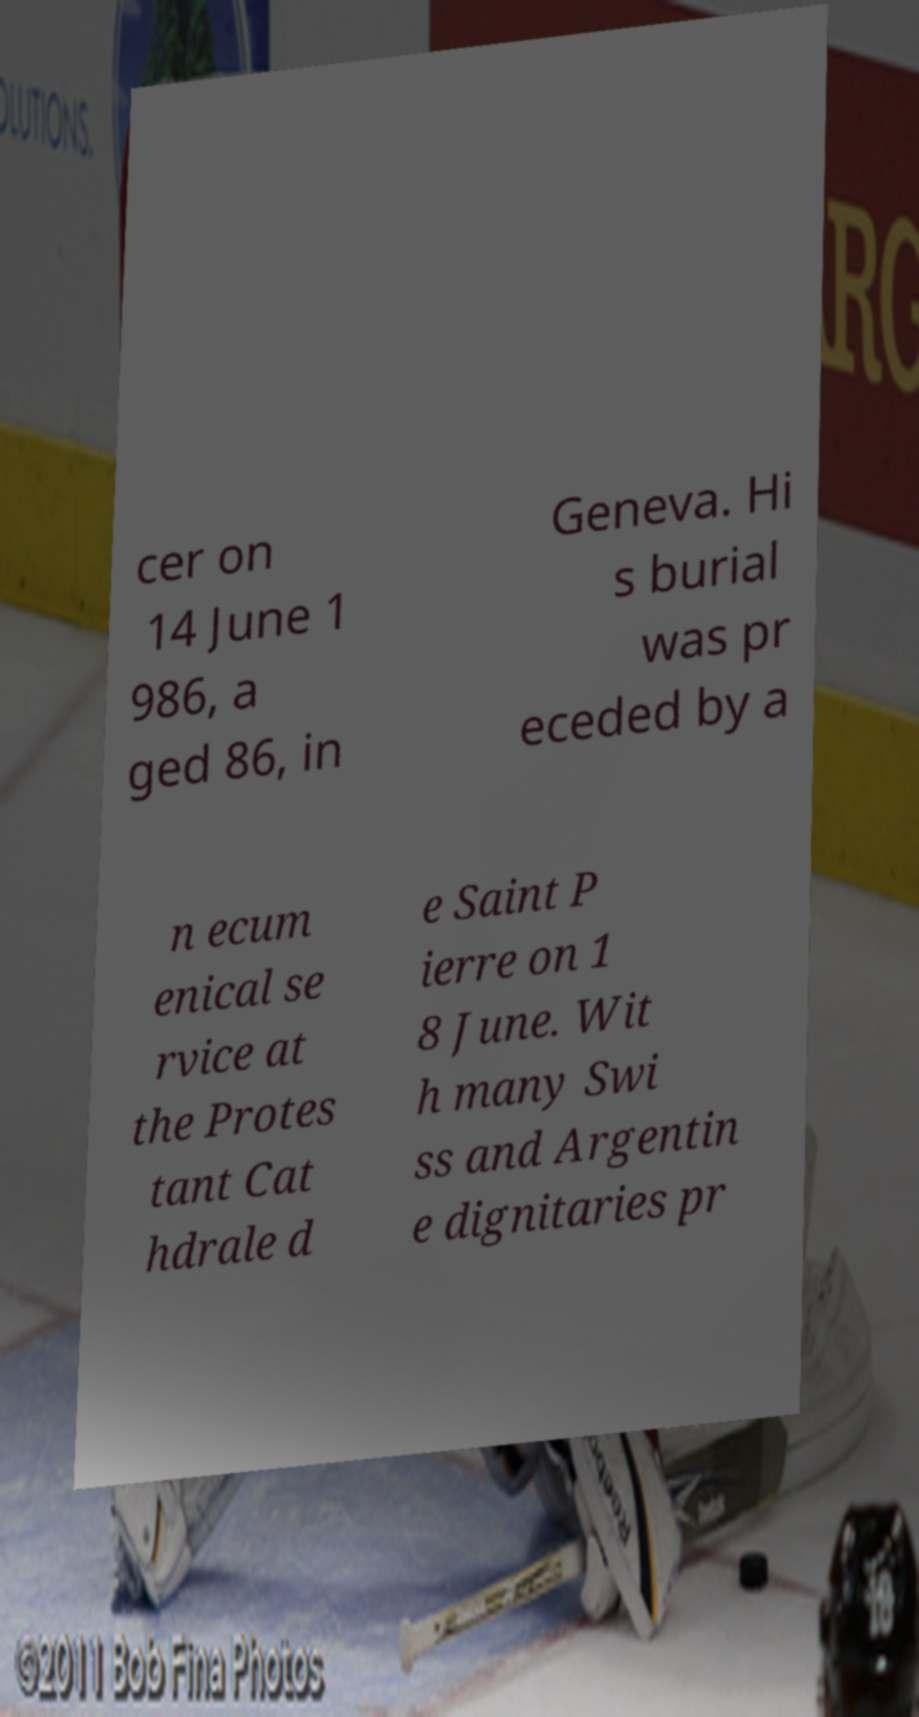Could you assist in decoding the text presented in this image and type it out clearly? cer on 14 June 1 986, a ged 86, in Geneva. Hi s burial was pr eceded by a n ecum enical se rvice at the Protes tant Cat hdrale d e Saint P ierre on 1 8 June. Wit h many Swi ss and Argentin e dignitaries pr 